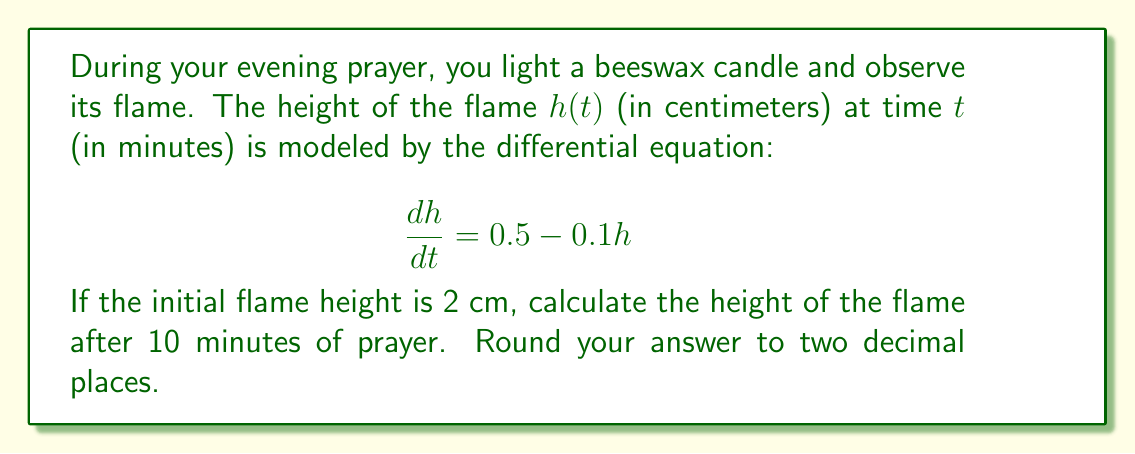What is the answer to this math problem? To solve this problem, we need to use the method for solving first-order linear differential equations.

1) The given differential equation is:
   $$\frac{dh}{dt} = 0.5 - 0.1h$$

2) This can be rewritten as:
   $$\frac{dh}{dt} + 0.1h = 0.5$$

3) The general solution for this type of equation is:
   $$h(t) = ce^{-0.1t} + 5$$
   where $c$ is a constant to be determined by the initial condition.

4) Given the initial condition $h(0) = 2$, we can find $c$:
   $$2 = ce^{-0.1(0)} + 5$$
   $$2 = c + 5$$
   $$c = -3$$

5) Therefore, the particular solution is:
   $$h(t) = -3e^{-0.1t} + 5$$

6) To find the height after 10 minutes, we substitute $t = 10$:
   $$h(10) = -3e^{-0.1(10)} + 5$$
   $$h(10) = -3e^{-1} + 5$$
   $$h(10) \approx -1.10 + 5 = 3.90$$

7) Rounding to two decimal places, we get 3.90 cm.
Answer: The height of the flame after 10 minutes of prayer is approximately 3.90 cm. 